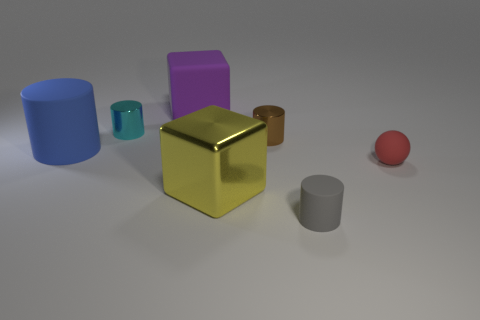Are there any other things that have the same size as the brown cylinder?
Your answer should be compact. Yes. Do the large matte cube and the tiny matte cylinder have the same color?
Your answer should be very brief. No. The small rubber object behind the gray object that is on the right side of the big rubber cylinder is what color?
Your answer should be very brief. Red. How many big things are green matte blocks or gray objects?
Your answer should be compact. 0. What color is the metal object that is both to the right of the cyan cylinder and left of the small brown cylinder?
Give a very brief answer. Yellow. Are the yellow object and the big cylinder made of the same material?
Your answer should be very brief. No. There is a cyan metal thing; what shape is it?
Your answer should be compact. Cylinder. How many brown shiny cylinders are behind the big block that is in front of the matte cylinder behind the red thing?
Ensure brevity in your answer.  1. What is the color of the other small rubber object that is the same shape as the blue object?
Give a very brief answer. Gray. The large blue rubber object left of the cube that is on the right side of the large cube behind the small brown shiny cylinder is what shape?
Your response must be concise. Cylinder. 